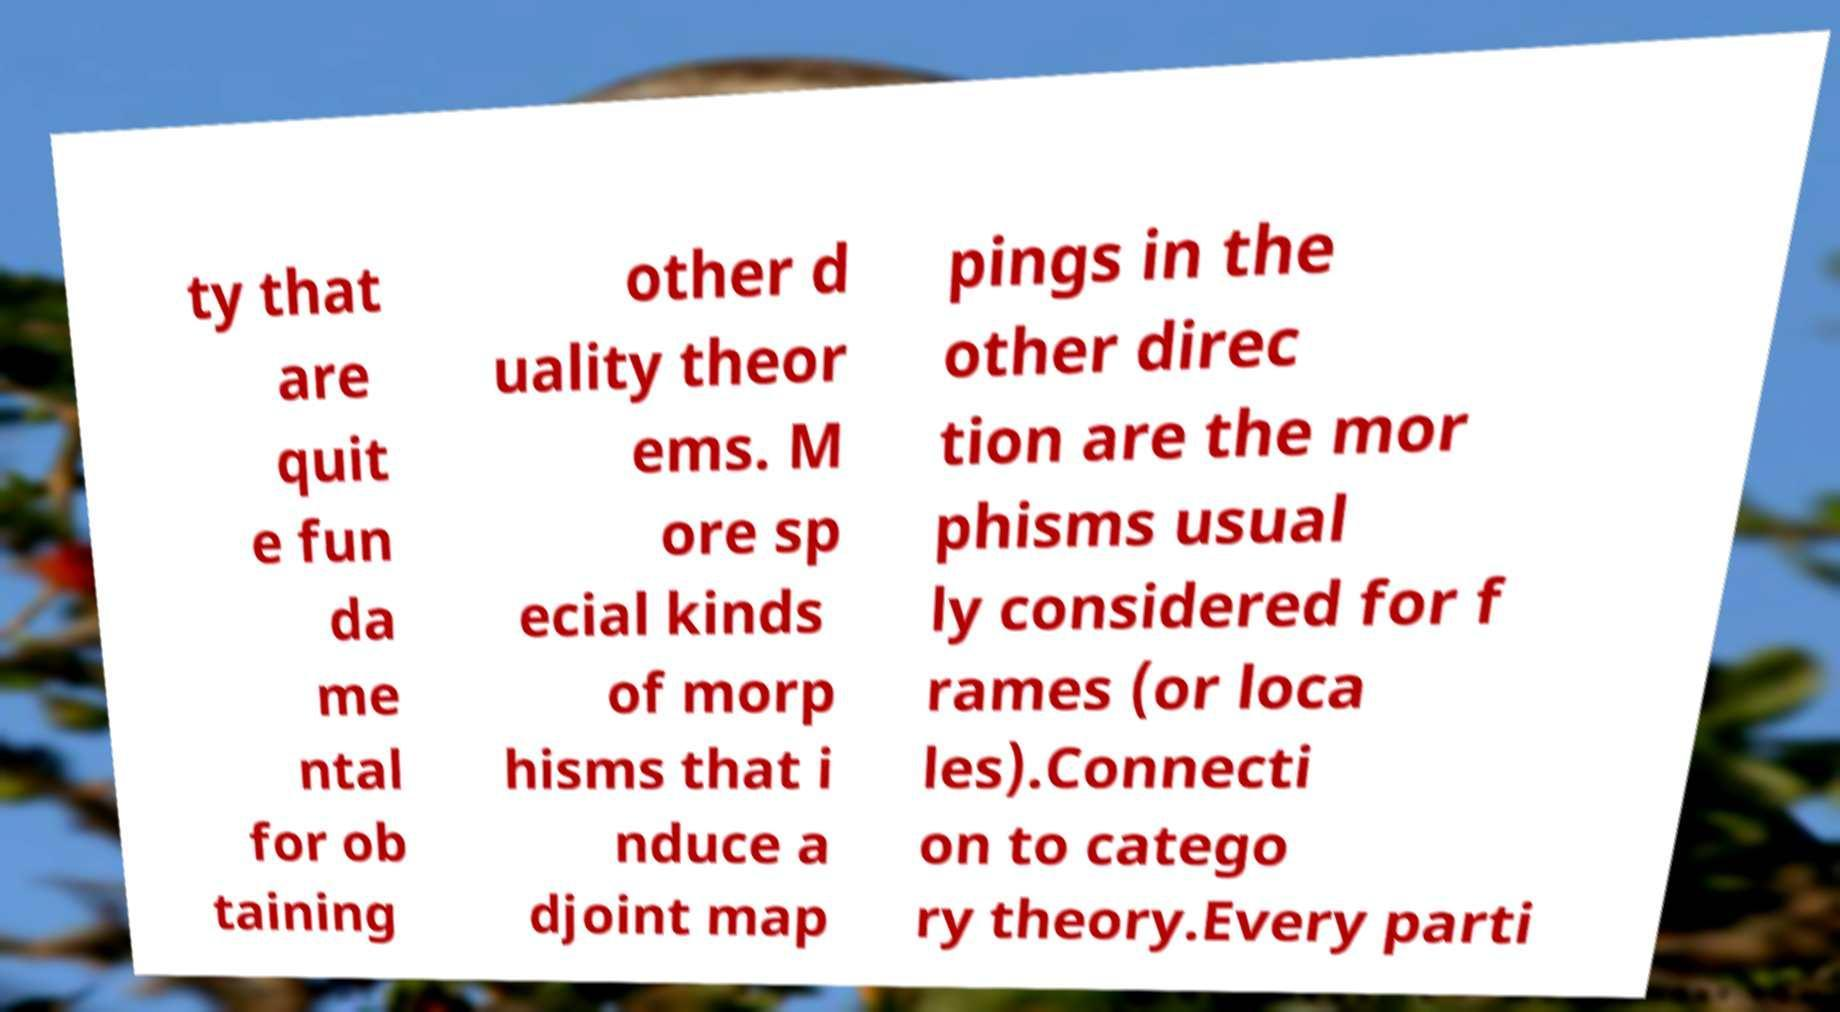Can you read and provide the text displayed in the image?This photo seems to have some interesting text. Can you extract and type it out for me? ty that are quit e fun da me ntal for ob taining other d uality theor ems. M ore sp ecial kinds of morp hisms that i nduce a djoint map pings in the other direc tion are the mor phisms usual ly considered for f rames (or loca les).Connecti on to catego ry theory.Every parti 